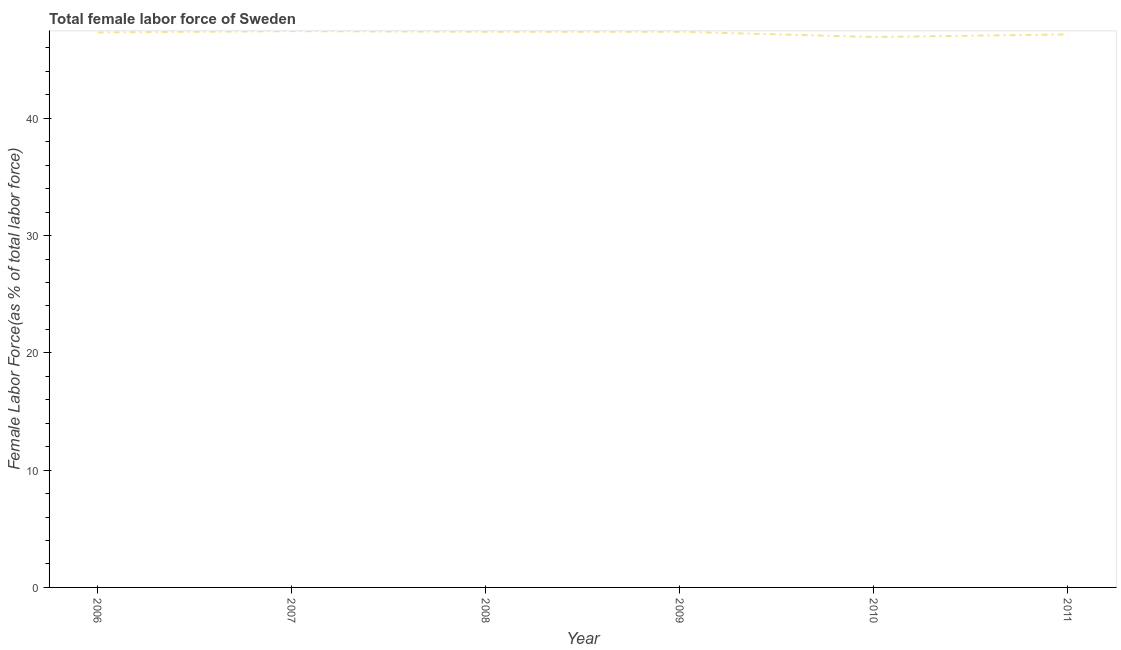What is the total female labor force in 2009?
Your answer should be compact. 47.38. Across all years, what is the maximum total female labor force?
Give a very brief answer. 47.44. Across all years, what is the minimum total female labor force?
Provide a short and direct response. 46.94. What is the sum of the total female labor force?
Ensure brevity in your answer.  283.62. What is the difference between the total female labor force in 2006 and 2009?
Your response must be concise. -0.06. What is the average total female labor force per year?
Provide a succinct answer. 47.27. What is the median total female labor force?
Make the answer very short. 47.35. Do a majority of the years between 2011 and 2008 (inclusive) have total female labor force greater than 30 %?
Make the answer very short. Yes. What is the ratio of the total female labor force in 2006 to that in 2008?
Your answer should be compact. 1. Is the total female labor force in 2008 less than that in 2010?
Provide a succinct answer. No. Is the difference between the total female labor force in 2008 and 2009 greater than the difference between any two years?
Keep it short and to the point. No. What is the difference between the highest and the second highest total female labor force?
Give a very brief answer. 0.05. What is the difference between the highest and the lowest total female labor force?
Give a very brief answer. 0.5. How many years are there in the graph?
Offer a very short reply. 6. Are the values on the major ticks of Y-axis written in scientific E-notation?
Keep it short and to the point. No. Does the graph contain any zero values?
Give a very brief answer. No. What is the title of the graph?
Offer a terse response. Total female labor force of Sweden. What is the label or title of the X-axis?
Offer a very short reply. Year. What is the label or title of the Y-axis?
Your response must be concise. Female Labor Force(as % of total labor force). What is the Female Labor Force(as % of total labor force) in 2006?
Make the answer very short. 47.32. What is the Female Labor Force(as % of total labor force) in 2007?
Provide a short and direct response. 47.44. What is the Female Labor Force(as % of total labor force) of 2008?
Your response must be concise. 47.38. What is the Female Labor Force(as % of total labor force) in 2009?
Offer a terse response. 47.38. What is the Female Labor Force(as % of total labor force) in 2010?
Your answer should be compact. 46.94. What is the Female Labor Force(as % of total labor force) of 2011?
Make the answer very short. 47.16. What is the difference between the Female Labor Force(as % of total labor force) in 2006 and 2007?
Make the answer very short. -0.11. What is the difference between the Female Labor Force(as % of total labor force) in 2006 and 2008?
Provide a succinct answer. -0.06. What is the difference between the Female Labor Force(as % of total labor force) in 2006 and 2009?
Ensure brevity in your answer.  -0.06. What is the difference between the Female Labor Force(as % of total labor force) in 2006 and 2010?
Make the answer very short. 0.39. What is the difference between the Female Labor Force(as % of total labor force) in 2006 and 2011?
Make the answer very short. 0.17. What is the difference between the Female Labor Force(as % of total labor force) in 2007 and 2008?
Offer a very short reply. 0.05. What is the difference between the Female Labor Force(as % of total labor force) in 2007 and 2009?
Your answer should be compact. 0.05. What is the difference between the Female Labor Force(as % of total labor force) in 2007 and 2010?
Ensure brevity in your answer.  0.5. What is the difference between the Female Labor Force(as % of total labor force) in 2007 and 2011?
Keep it short and to the point. 0.28. What is the difference between the Female Labor Force(as % of total labor force) in 2008 and 2009?
Provide a succinct answer. -0. What is the difference between the Female Labor Force(as % of total labor force) in 2008 and 2010?
Offer a very short reply. 0.45. What is the difference between the Female Labor Force(as % of total labor force) in 2008 and 2011?
Keep it short and to the point. 0.23. What is the difference between the Female Labor Force(as % of total labor force) in 2009 and 2010?
Keep it short and to the point. 0.45. What is the difference between the Female Labor Force(as % of total labor force) in 2009 and 2011?
Provide a succinct answer. 0.23. What is the difference between the Female Labor Force(as % of total labor force) in 2010 and 2011?
Offer a terse response. -0.22. What is the ratio of the Female Labor Force(as % of total labor force) in 2006 to that in 2007?
Ensure brevity in your answer.  1. What is the ratio of the Female Labor Force(as % of total labor force) in 2006 to that in 2008?
Give a very brief answer. 1. What is the ratio of the Female Labor Force(as % of total labor force) in 2006 to that in 2009?
Your answer should be very brief. 1. What is the ratio of the Female Labor Force(as % of total labor force) in 2006 to that in 2010?
Give a very brief answer. 1.01. What is the ratio of the Female Labor Force(as % of total labor force) in 2007 to that in 2008?
Keep it short and to the point. 1. What is the ratio of the Female Labor Force(as % of total labor force) in 2007 to that in 2009?
Your response must be concise. 1. What is the ratio of the Female Labor Force(as % of total labor force) in 2007 to that in 2011?
Make the answer very short. 1.01. What is the ratio of the Female Labor Force(as % of total labor force) in 2008 to that in 2009?
Give a very brief answer. 1. What is the ratio of the Female Labor Force(as % of total labor force) in 2008 to that in 2010?
Make the answer very short. 1.01. What is the ratio of the Female Labor Force(as % of total labor force) in 2009 to that in 2010?
Keep it short and to the point. 1.01. 